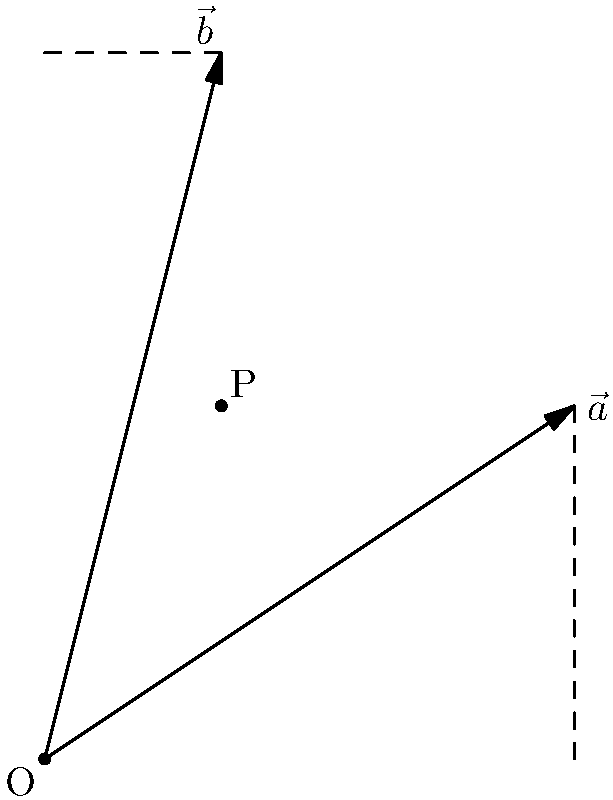In the context of cognitive load theory, which emphasizes the importance of visual representations in learning, consider the following 2D vector diagram. Vector $\vec{a}$ has components (3,2) and vector $\vec{b}$ has components (1,4). What is the dot product of these two vectors, and how does this relate to the projection of one vector onto the other? Let's approach this step-by-step:

1) The dot product of two vectors $\vec{a}(a_1, a_2)$ and $\vec{b}(b_1, b_2)$ in 2D space is defined as:

   $$\vec{a} \cdot \vec{b} = a_1b_1 + a_2b_2$$

2) For the given vectors:
   $\vec{a} = (3,2)$ and $\vec{b} = (1,4)$

3) Calculating the dot product:
   $$\vec{a} \cdot \vec{b} = (3)(1) + (2)(4) = 3 + 8 = 11$$

4) The dot product can also be expressed as:
   $$\vec{a} \cdot \vec{b} = |\vec{a}||\vec{b}|\cos\theta$$
   where $\theta$ is the angle between the vectors.

5) This formula relates to the projection of one vector onto the other. The scalar projection of $\vec{a}$ onto $\vec{b}$ is:
   $$\text{proj}_{\vec{b}}\vec{a} = \frac{\vec{a} \cdot \vec{b}}{|\vec{b}|}$$

6) The dot product, therefore, represents the product of the magnitude of one vector and the scalar projection of the other vector onto it.

7) Visually, in our diagram, if we drop a perpendicular from the tip of $\vec{a}$ to $\vec{b}$ (or vice versa), the length of this perpendicular multiplied by the magnitude of $\vec{b}$ (or $\vec{a}$) would give us the dot product.

This visual representation helps reduce cognitive load for students by providing a concrete image to associate with the abstract concept of dot product.
Answer: 11 